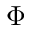<formula> <loc_0><loc_0><loc_500><loc_500>\Phi</formula> 